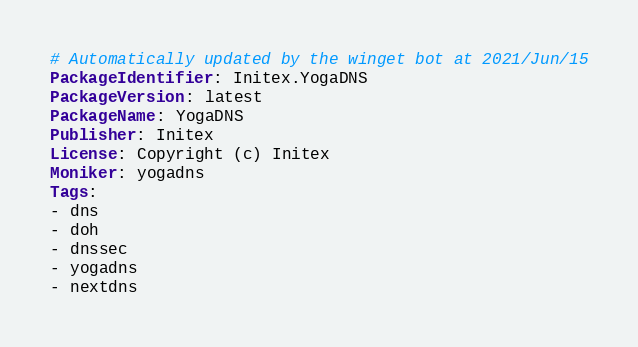Convert code to text. <code><loc_0><loc_0><loc_500><loc_500><_YAML_># Automatically updated by the winget bot at 2021/Jun/15
PackageIdentifier: Initex.YogaDNS
PackageVersion: latest
PackageName: YogaDNS
Publisher: Initex
License: Copyright (c) Initex
Moniker: yogadns
Tags:
- dns
- doh
- dnssec
- yogadns
- nextdns</code> 